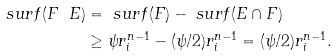Convert formula to latex. <formula><loc_0><loc_0><loc_500><loc_500>\ s u r f ( F \ E ) & = \ s u r f ( F ) - \ s u r f ( E \cap F ) \\ & \geq \psi r _ { i } ^ { n - 1 } - ( \psi / 2 ) r _ { i } ^ { n - 1 } = ( \psi / 2 ) r _ { i } ^ { n - 1 } .</formula> 